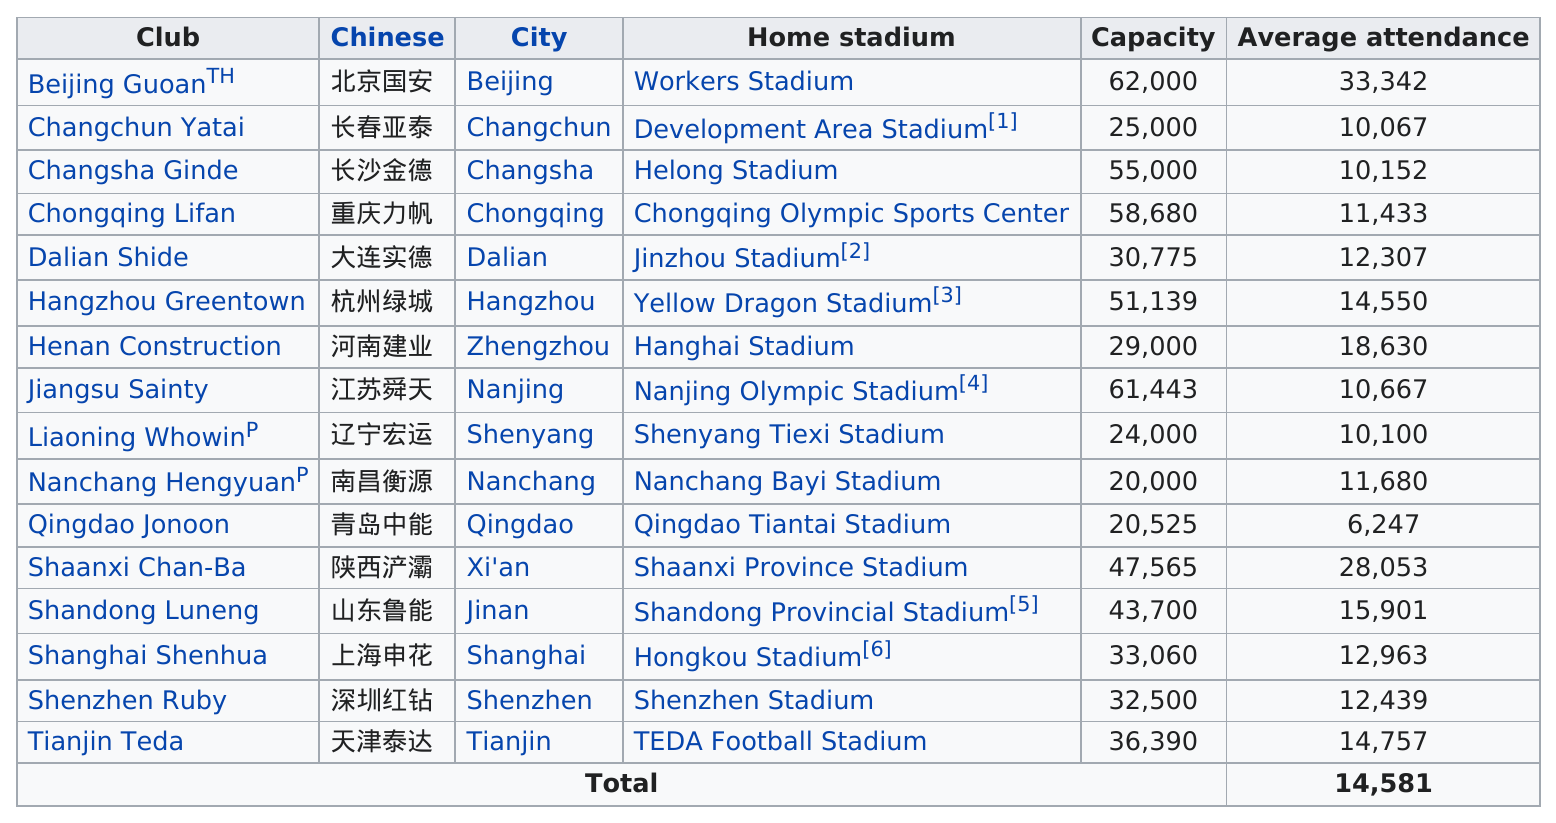Identify some key points in this picture. In total, there are 16 home stadiums for the 2010 Chinese Super League clubs. There are only two Chinese Super League stadiums that can accommodate at least 60,000 people. Qingdao Tiantai Stadium has the least number of average attendees compared to other stadiums. The average attendance for all stadiums is 14,581. There are 16 clubs listed in the table. 